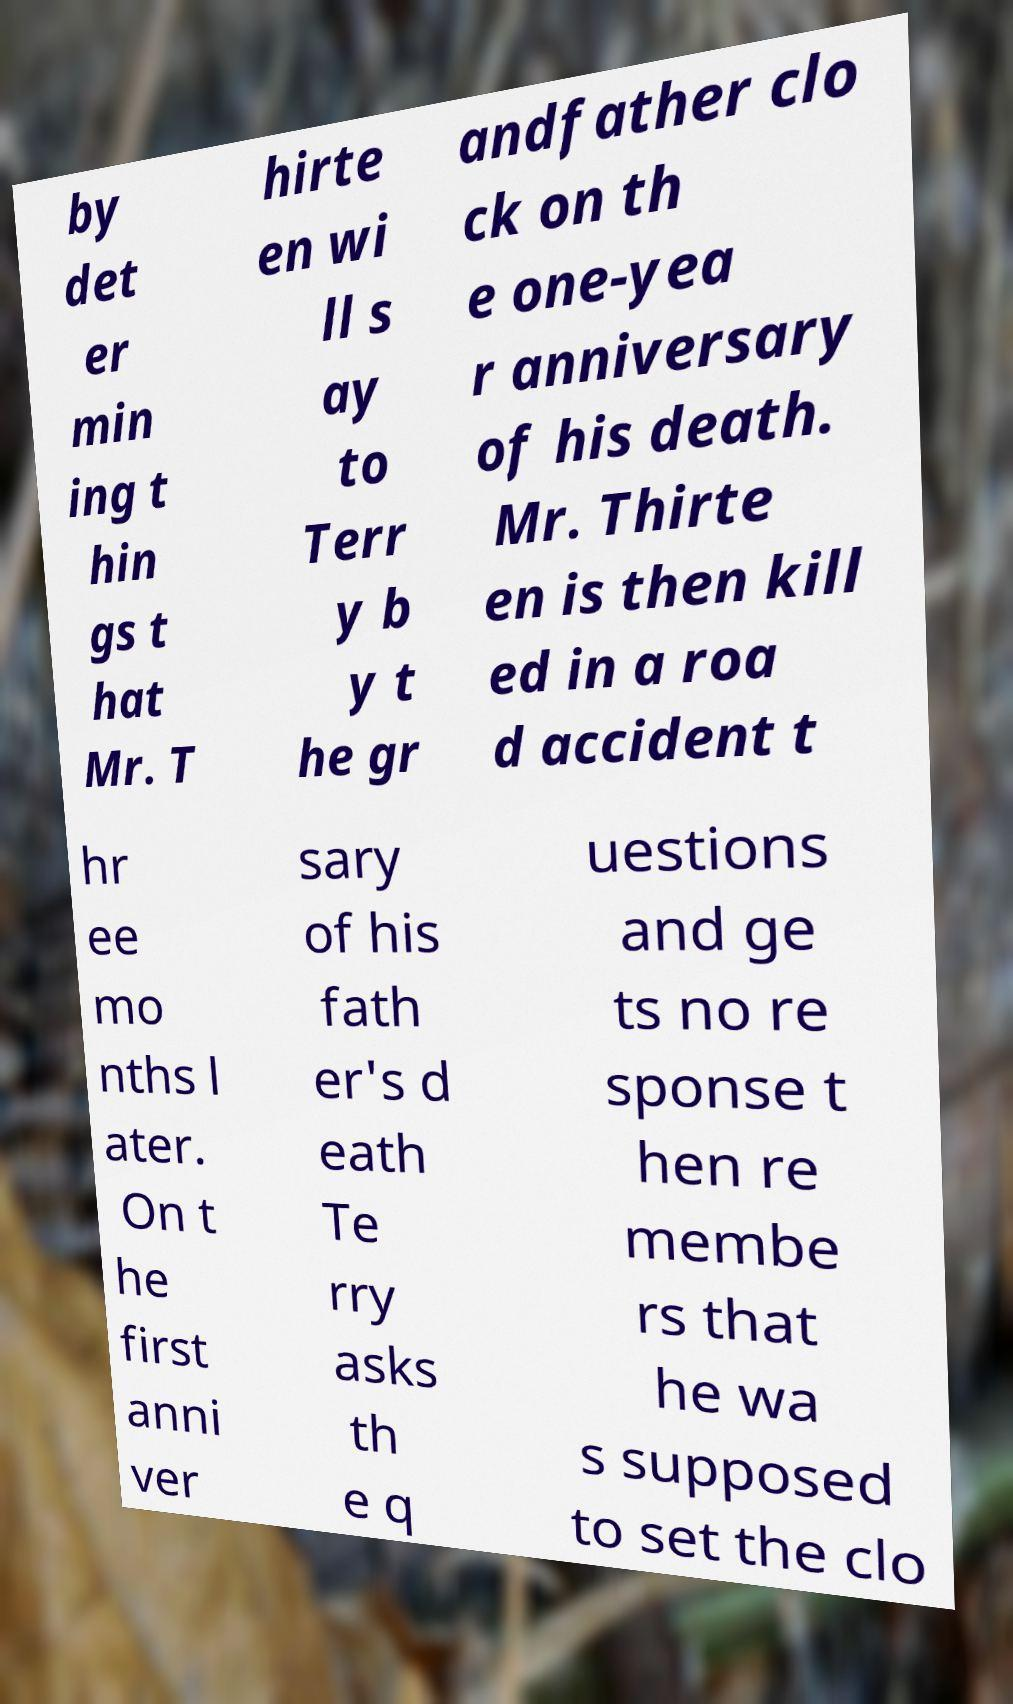Please read and relay the text visible in this image. What does it say? by det er min ing t hin gs t hat Mr. T hirte en wi ll s ay to Terr y b y t he gr andfather clo ck on th e one-yea r anniversary of his death. Mr. Thirte en is then kill ed in a roa d accident t hr ee mo nths l ater. On t he first anni ver sary of his fath er's d eath Te rry asks th e q uestions and ge ts no re sponse t hen re membe rs that he wa s supposed to set the clo 